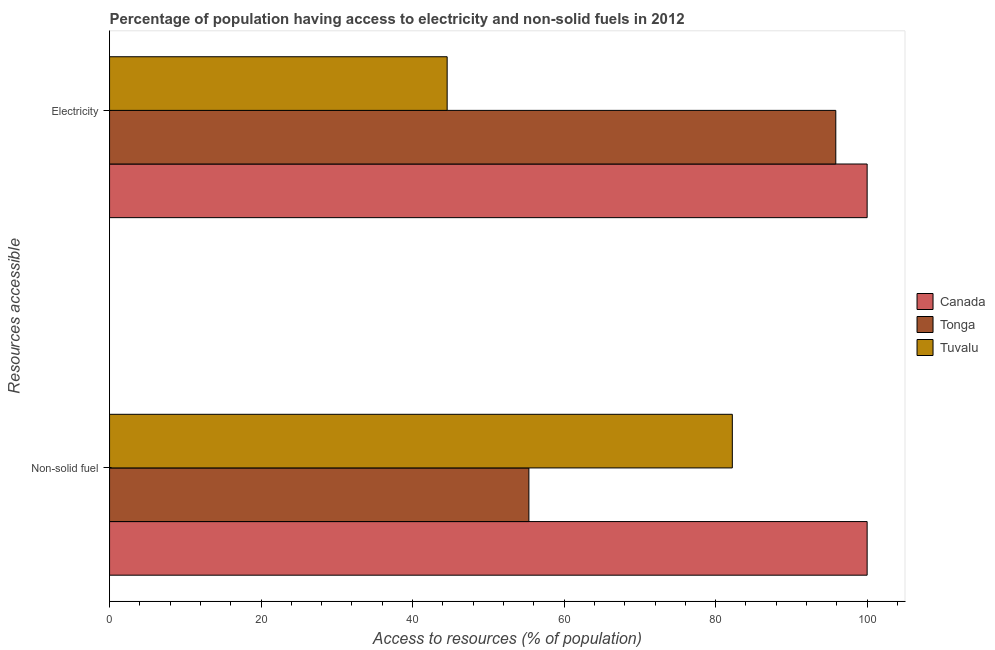How many different coloured bars are there?
Your answer should be compact. 3. How many groups of bars are there?
Ensure brevity in your answer.  2. Are the number of bars per tick equal to the number of legend labels?
Your answer should be compact. Yes. How many bars are there on the 1st tick from the bottom?
Provide a succinct answer. 3. What is the label of the 1st group of bars from the top?
Keep it short and to the point. Electricity. What is the percentage of population having access to electricity in Tuvalu?
Your answer should be compact. 44.56. Across all countries, what is the minimum percentage of population having access to electricity?
Provide a succinct answer. 44.56. In which country was the percentage of population having access to non-solid fuel minimum?
Keep it short and to the point. Tonga. What is the total percentage of population having access to electricity in the graph?
Your answer should be very brief. 240.43. What is the difference between the percentage of population having access to electricity in Tuvalu and that in Canada?
Provide a succinct answer. -55.44. What is the difference between the percentage of population having access to non-solid fuel in Canada and the percentage of population having access to electricity in Tuvalu?
Your answer should be very brief. 55.44. What is the average percentage of population having access to non-solid fuel per country?
Provide a short and direct response. 79.19. What is the difference between the percentage of population having access to electricity and percentage of population having access to non-solid fuel in Canada?
Your response must be concise. 0. In how many countries, is the percentage of population having access to electricity greater than 16 %?
Provide a succinct answer. 3. What is the ratio of the percentage of population having access to non-solid fuel in Tonga to that in Canada?
Keep it short and to the point. 0.55. Is the percentage of population having access to electricity in Tuvalu less than that in Tonga?
Ensure brevity in your answer.  Yes. In how many countries, is the percentage of population having access to electricity greater than the average percentage of population having access to electricity taken over all countries?
Your response must be concise. 2. What does the 1st bar from the top in Electricity represents?
Your answer should be very brief. Tuvalu. How many bars are there?
Your answer should be compact. 6. How many countries are there in the graph?
Your answer should be compact. 3. Are the values on the major ticks of X-axis written in scientific E-notation?
Keep it short and to the point. No. How are the legend labels stacked?
Provide a succinct answer. Vertical. What is the title of the graph?
Provide a short and direct response. Percentage of population having access to electricity and non-solid fuels in 2012. Does "Qatar" appear as one of the legend labels in the graph?
Provide a succinct answer. No. What is the label or title of the X-axis?
Keep it short and to the point. Access to resources (% of population). What is the label or title of the Y-axis?
Your answer should be very brief. Resources accessible. What is the Access to resources (% of population) of Canada in Non-solid fuel?
Your answer should be very brief. 100. What is the Access to resources (% of population) in Tonga in Non-solid fuel?
Ensure brevity in your answer.  55.35. What is the Access to resources (% of population) of Tuvalu in Non-solid fuel?
Your response must be concise. 82.21. What is the Access to resources (% of population) of Canada in Electricity?
Offer a very short reply. 100. What is the Access to resources (% of population) in Tonga in Electricity?
Your answer should be compact. 95.86. What is the Access to resources (% of population) of Tuvalu in Electricity?
Keep it short and to the point. 44.56. Across all Resources accessible, what is the maximum Access to resources (% of population) in Canada?
Give a very brief answer. 100. Across all Resources accessible, what is the maximum Access to resources (% of population) in Tonga?
Keep it short and to the point. 95.86. Across all Resources accessible, what is the maximum Access to resources (% of population) of Tuvalu?
Give a very brief answer. 82.21. Across all Resources accessible, what is the minimum Access to resources (% of population) of Canada?
Ensure brevity in your answer.  100. Across all Resources accessible, what is the minimum Access to resources (% of population) of Tonga?
Your answer should be compact. 55.35. Across all Resources accessible, what is the minimum Access to resources (% of population) in Tuvalu?
Your response must be concise. 44.56. What is the total Access to resources (% of population) of Tonga in the graph?
Ensure brevity in your answer.  151.21. What is the total Access to resources (% of population) in Tuvalu in the graph?
Offer a very short reply. 126.77. What is the difference between the Access to resources (% of population) of Tonga in Non-solid fuel and that in Electricity?
Provide a short and direct response. -40.51. What is the difference between the Access to resources (% of population) of Tuvalu in Non-solid fuel and that in Electricity?
Keep it short and to the point. 37.64. What is the difference between the Access to resources (% of population) in Canada in Non-solid fuel and the Access to resources (% of population) in Tonga in Electricity?
Your answer should be compact. 4.14. What is the difference between the Access to resources (% of population) in Canada in Non-solid fuel and the Access to resources (% of population) in Tuvalu in Electricity?
Provide a short and direct response. 55.44. What is the difference between the Access to resources (% of population) of Tonga in Non-solid fuel and the Access to resources (% of population) of Tuvalu in Electricity?
Give a very brief answer. 10.79. What is the average Access to resources (% of population) of Tonga per Resources accessible?
Offer a very short reply. 75.61. What is the average Access to resources (% of population) in Tuvalu per Resources accessible?
Provide a short and direct response. 63.38. What is the difference between the Access to resources (% of population) of Canada and Access to resources (% of population) of Tonga in Non-solid fuel?
Your response must be concise. 44.65. What is the difference between the Access to resources (% of population) of Canada and Access to resources (% of population) of Tuvalu in Non-solid fuel?
Make the answer very short. 17.79. What is the difference between the Access to resources (% of population) in Tonga and Access to resources (% of population) in Tuvalu in Non-solid fuel?
Ensure brevity in your answer.  -26.85. What is the difference between the Access to resources (% of population) in Canada and Access to resources (% of population) in Tonga in Electricity?
Keep it short and to the point. 4.14. What is the difference between the Access to resources (% of population) in Canada and Access to resources (% of population) in Tuvalu in Electricity?
Keep it short and to the point. 55.44. What is the difference between the Access to resources (% of population) in Tonga and Access to resources (% of population) in Tuvalu in Electricity?
Give a very brief answer. 51.3. What is the ratio of the Access to resources (% of population) in Tonga in Non-solid fuel to that in Electricity?
Keep it short and to the point. 0.58. What is the ratio of the Access to resources (% of population) of Tuvalu in Non-solid fuel to that in Electricity?
Provide a short and direct response. 1.84. What is the difference between the highest and the second highest Access to resources (% of population) in Tonga?
Keep it short and to the point. 40.51. What is the difference between the highest and the second highest Access to resources (% of population) in Tuvalu?
Make the answer very short. 37.64. What is the difference between the highest and the lowest Access to resources (% of population) of Canada?
Your answer should be very brief. 0. What is the difference between the highest and the lowest Access to resources (% of population) in Tonga?
Your answer should be compact. 40.51. What is the difference between the highest and the lowest Access to resources (% of population) of Tuvalu?
Provide a short and direct response. 37.64. 